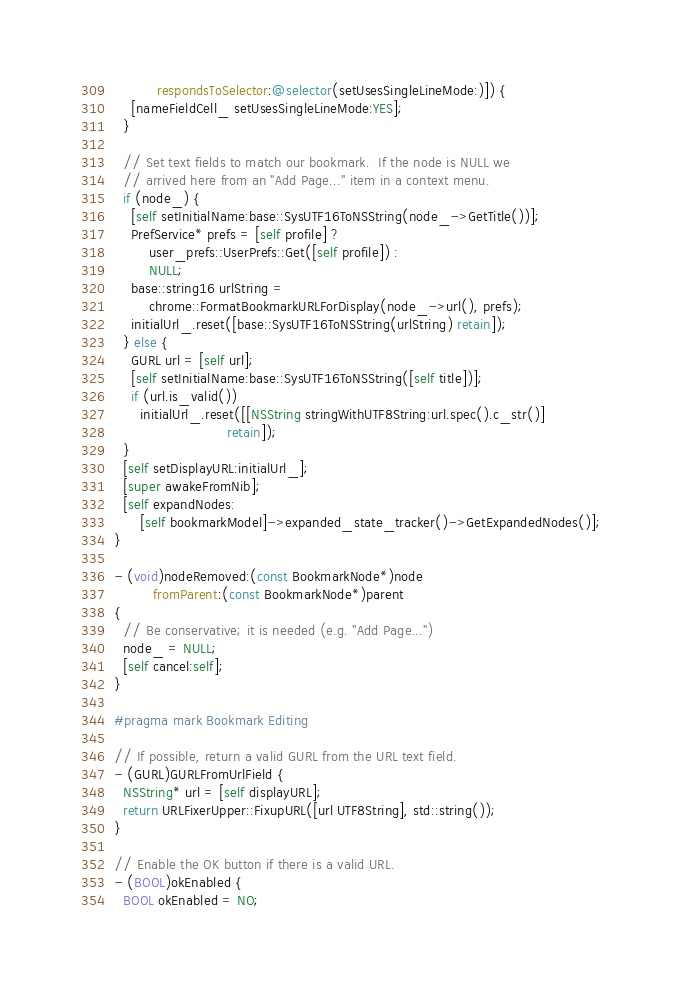<code> <loc_0><loc_0><loc_500><loc_500><_ObjectiveC_>          respondsToSelector:@selector(setUsesSingleLineMode:)]) {
    [nameFieldCell_ setUsesSingleLineMode:YES];
  }

  // Set text fields to match our bookmark.  If the node is NULL we
  // arrived here from an "Add Page..." item in a context menu.
  if (node_) {
    [self setInitialName:base::SysUTF16ToNSString(node_->GetTitle())];
    PrefService* prefs = [self profile] ?
        user_prefs::UserPrefs::Get([self profile]) :
        NULL;
    base::string16 urlString =
        chrome::FormatBookmarkURLForDisplay(node_->url(), prefs);
    initialUrl_.reset([base::SysUTF16ToNSString(urlString) retain]);
  } else {
    GURL url = [self url];
    [self setInitialName:base::SysUTF16ToNSString([self title])];
    if (url.is_valid())
      initialUrl_.reset([[NSString stringWithUTF8String:url.spec().c_str()]
                          retain]);
  }
  [self setDisplayURL:initialUrl_];
  [super awakeFromNib];
  [self expandNodes:
      [self bookmarkModel]->expanded_state_tracker()->GetExpandedNodes()];
}

- (void)nodeRemoved:(const BookmarkNode*)node
         fromParent:(const BookmarkNode*)parent
{
  // Be conservative; it is needed (e.g. "Add Page...")
  node_ = NULL;
  [self cancel:self];
}

#pragma mark Bookmark Editing

// If possible, return a valid GURL from the URL text field.
- (GURL)GURLFromUrlField {
  NSString* url = [self displayURL];
  return URLFixerUpper::FixupURL([url UTF8String], std::string());
}

// Enable the OK button if there is a valid URL.
- (BOOL)okEnabled {
  BOOL okEnabled = NO;</code> 